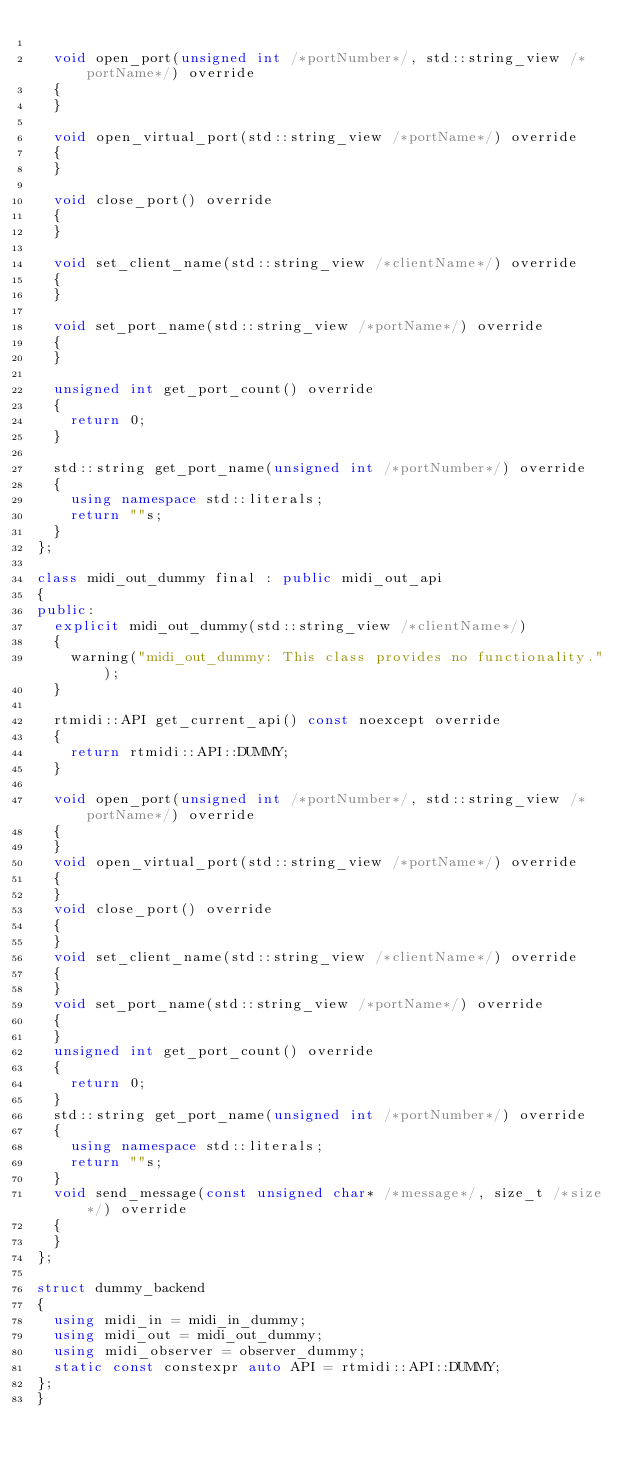Convert code to text. <code><loc_0><loc_0><loc_500><loc_500><_C++_>
  void open_port(unsigned int /*portNumber*/, std::string_view /*portName*/) override
  {
  }

  void open_virtual_port(std::string_view /*portName*/) override
  {
  }

  void close_port() override
  {
  }

  void set_client_name(std::string_view /*clientName*/) override
  {
  }

  void set_port_name(std::string_view /*portName*/) override
  {
  }

  unsigned int get_port_count() override
  {
    return 0;
  }

  std::string get_port_name(unsigned int /*portNumber*/) override
  {
    using namespace std::literals;
    return ""s;
  }
};

class midi_out_dummy final : public midi_out_api
{
public:
  explicit midi_out_dummy(std::string_view /*clientName*/)
  {
    warning("midi_out_dummy: This class provides no functionality.");
  }

  rtmidi::API get_current_api() const noexcept override
  {
    return rtmidi::API::DUMMY;
  }

  void open_port(unsigned int /*portNumber*/, std::string_view /*portName*/) override
  {
  }
  void open_virtual_port(std::string_view /*portName*/) override
  {
  }
  void close_port() override
  {
  }
  void set_client_name(std::string_view /*clientName*/) override
  {
  }
  void set_port_name(std::string_view /*portName*/) override
  {
  }
  unsigned int get_port_count() override
  {
    return 0;
  }
  std::string get_port_name(unsigned int /*portNumber*/) override
  {
    using namespace std::literals;
    return ""s;
  }
  void send_message(const unsigned char* /*message*/, size_t /*size*/) override
  {
  }
};

struct dummy_backend
{
  using midi_in = midi_in_dummy;
  using midi_out = midi_out_dummy;
  using midi_observer = observer_dummy;
  static const constexpr auto API = rtmidi::API::DUMMY;
};
}
</code> 